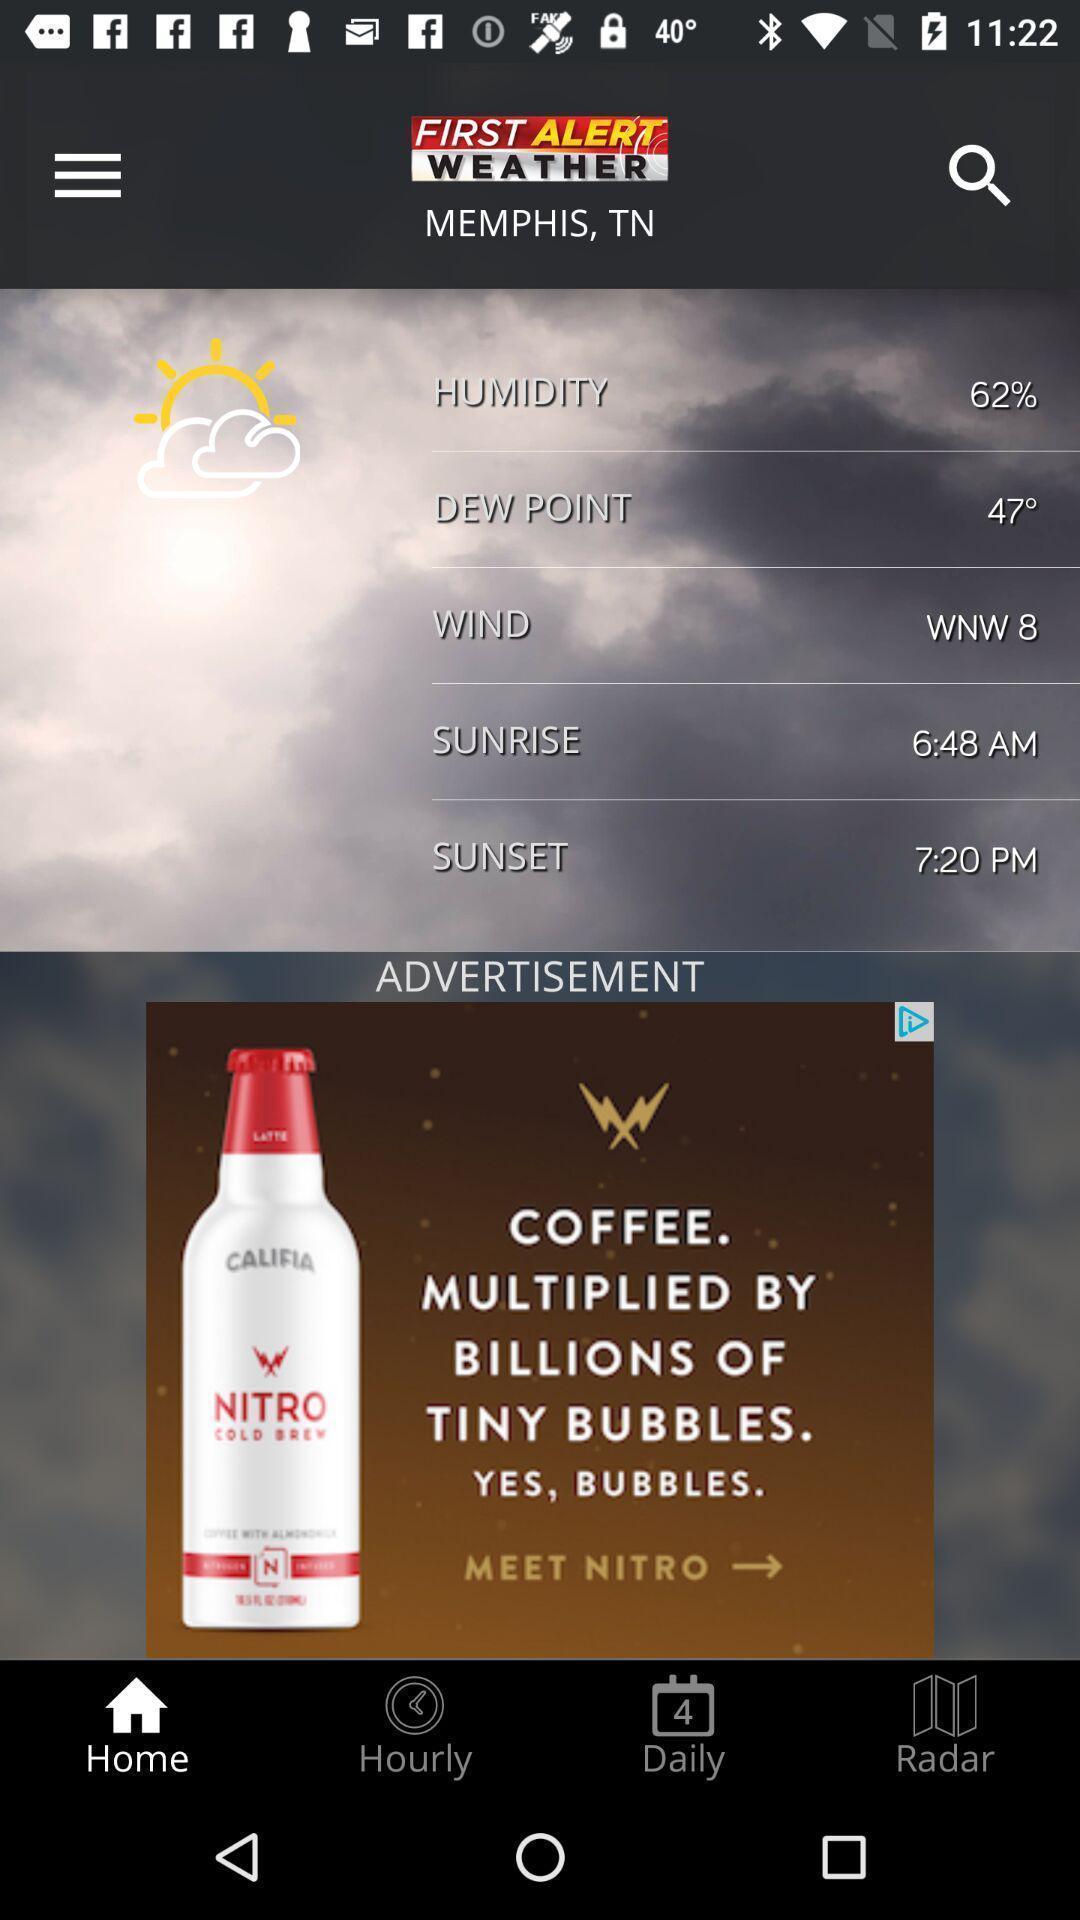Describe the key features of this screenshot. Weather forecasting based on location. 